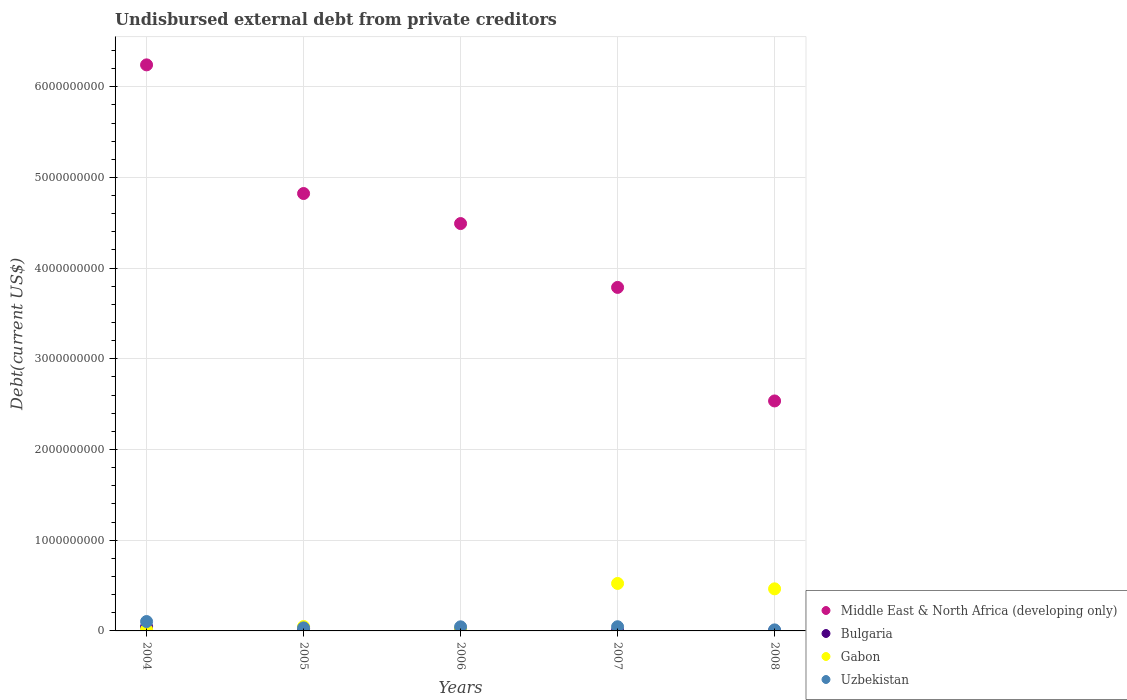How many different coloured dotlines are there?
Your answer should be compact. 4. What is the total debt in Gabon in 2006?
Your answer should be compact. 2.54e+07. Across all years, what is the maximum total debt in Gabon?
Make the answer very short. 5.23e+08. Across all years, what is the minimum total debt in Uzbekistan?
Make the answer very short. 1.14e+07. In which year was the total debt in Gabon maximum?
Provide a short and direct response. 2007. What is the total total debt in Gabon in the graph?
Your answer should be compact. 1.08e+09. What is the difference between the total debt in Uzbekistan in 2004 and that in 2005?
Offer a very short reply. 7.00e+07. What is the difference between the total debt in Uzbekistan in 2005 and the total debt in Gabon in 2008?
Your response must be concise. -4.30e+08. What is the average total debt in Uzbekistan per year?
Provide a short and direct response. 4.79e+07. In the year 2006, what is the difference between the total debt in Middle East & North Africa (developing only) and total debt in Bulgaria?
Give a very brief answer. 4.48e+09. What is the ratio of the total debt in Middle East & North Africa (developing only) in 2007 to that in 2008?
Your answer should be very brief. 1.49. Is the total debt in Uzbekistan in 2005 less than that in 2007?
Make the answer very short. Yes. What is the difference between the highest and the second highest total debt in Bulgaria?
Your response must be concise. 1.85e+07. What is the difference between the highest and the lowest total debt in Middle East & North Africa (developing only)?
Offer a very short reply. 3.71e+09. In how many years, is the total debt in Gabon greater than the average total debt in Gabon taken over all years?
Offer a terse response. 2. Is the sum of the total debt in Bulgaria in 2006 and 2007 greater than the maximum total debt in Uzbekistan across all years?
Offer a very short reply. No. How many dotlines are there?
Provide a short and direct response. 4. Are the values on the major ticks of Y-axis written in scientific E-notation?
Make the answer very short. No. Does the graph contain any zero values?
Make the answer very short. No. Where does the legend appear in the graph?
Give a very brief answer. Bottom right. How are the legend labels stacked?
Give a very brief answer. Vertical. What is the title of the graph?
Provide a succinct answer. Undisbursed external debt from private creditors. What is the label or title of the Y-axis?
Offer a very short reply. Debt(current US$). What is the Debt(current US$) of Middle East & North Africa (developing only) in 2004?
Offer a terse response. 6.24e+09. What is the Debt(current US$) in Bulgaria in 2004?
Offer a terse response. 4.61e+07. What is the Debt(current US$) of Gabon in 2004?
Your answer should be very brief. 1.48e+07. What is the Debt(current US$) of Uzbekistan in 2004?
Keep it short and to the point. 1.03e+08. What is the Debt(current US$) in Middle East & North Africa (developing only) in 2005?
Offer a very short reply. 4.82e+09. What is the Debt(current US$) of Bulgaria in 2005?
Make the answer very short. 2.76e+07. What is the Debt(current US$) in Gabon in 2005?
Your response must be concise. 4.86e+07. What is the Debt(current US$) of Uzbekistan in 2005?
Your response must be concise. 3.35e+07. What is the Debt(current US$) of Middle East & North Africa (developing only) in 2006?
Ensure brevity in your answer.  4.49e+09. What is the Debt(current US$) in Bulgaria in 2006?
Provide a succinct answer. 1.13e+07. What is the Debt(current US$) in Gabon in 2006?
Offer a terse response. 2.54e+07. What is the Debt(current US$) of Uzbekistan in 2006?
Your response must be concise. 4.53e+07. What is the Debt(current US$) in Middle East & North Africa (developing only) in 2007?
Provide a succinct answer. 3.79e+09. What is the Debt(current US$) of Bulgaria in 2007?
Your response must be concise. 4.57e+06. What is the Debt(current US$) in Gabon in 2007?
Offer a very short reply. 5.23e+08. What is the Debt(current US$) in Uzbekistan in 2007?
Your response must be concise. 4.61e+07. What is the Debt(current US$) of Middle East & North Africa (developing only) in 2008?
Your answer should be very brief. 2.54e+09. What is the Debt(current US$) of Bulgaria in 2008?
Your response must be concise. 2.36e+06. What is the Debt(current US$) of Gabon in 2008?
Offer a very short reply. 4.64e+08. What is the Debt(current US$) in Uzbekistan in 2008?
Ensure brevity in your answer.  1.14e+07. Across all years, what is the maximum Debt(current US$) in Middle East & North Africa (developing only)?
Keep it short and to the point. 6.24e+09. Across all years, what is the maximum Debt(current US$) of Bulgaria?
Your answer should be very brief. 4.61e+07. Across all years, what is the maximum Debt(current US$) of Gabon?
Your answer should be very brief. 5.23e+08. Across all years, what is the maximum Debt(current US$) of Uzbekistan?
Your answer should be very brief. 1.03e+08. Across all years, what is the minimum Debt(current US$) of Middle East & North Africa (developing only)?
Ensure brevity in your answer.  2.54e+09. Across all years, what is the minimum Debt(current US$) in Bulgaria?
Your answer should be compact. 2.36e+06. Across all years, what is the minimum Debt(current US$) in Gabon?
Give a very brief answer. 1.48e+07. Across all years, what is the minimum Debt(current US$) in Uzbekistan?
Keep it short and to the point. 1.14e+07. What is the total Debt(current US$) in Middle East & North Africa (developing only) in the graph?
Your response must be concise. 2.19e+1. What is the total Debt(current US$) of Bulgaria in the graph?
Your answer should be very brief. 9.19e+07. What is the total Debt(current US$) in Gabon in the graph?
Give a very brief answer. 1.08e+09. What is the total Debt(current US$) in Uzbekistan in the graph?
Provide a short and direct response. 2.40e+08. What is the difference between the Debt(current US$) of Middle East & North Africa (developing only) in 2004 and that in 2005?
Ensure brevity in your answer.  1.42e+09. What is the difference between the Debt(current US$) of Bulgaria in 2004 and that in 2005?
Your answer should be very brief. 1.85e+07. What is the difference between the Debt(current US$) of Gabon in 2004 and that in 2005?
Offer a terse response. -3.39e+07. What is the difference between the Debt(current US$) of Uzbekistan in 2004 and that in 2005?
Your answer should be very brief. 7.00e+07. What is the difference between the Debt(current US$) of Middle East & North Africa (developing only) in 2004 and that in 2006?
Offer a terse response. 1.75e+09. What is the difference between the Debt(current US$) in Bulgaria in 2004 and that in 2006?
Provide a succinct answer. 3.48e+07. What is the difference between the Debt(current US$) in Gabon in 2004 and that in 2006?
Provide a short and direct response. -1.07e+07. What is the difference between the Debt(current US$) in Uzbekistan in 2004 and that in 2006?
Offer a terse response. 5.82e+07. What is the difference between the Debt(current US$) in Middle East & North Africa (developing only) in 2004 and that in 2007?
Give a very brief answer. 2.45e+09. What is the difference between the Debt(current US$) of Bulgaria in 2004 and that in 2007?
Give a very brief answer. 4.15e+07. What is the difference between the Debt(current US$) of Gabon in 2004 and that in 2007?
Ensure brevity in your answer.  -5.09e+08. What is the difference between the Debt(current US$) in Uzbekistan in 2004 and that in 2007?
Keep it short and to the point. 5.74e+07. What is the difference between the Debt(current US$) in Middle East & North Africa (developing only) in 2004 and that in 2008?
Give a very brief answer. 3.71e+09. What is the difference between the Debt(current US$) of Bulgaria in 2004 and that in 2008?
Your answer should be compact. 4.37e+07. What is the difference between the Debt(current US$) of Gabon in 2004 and that in 2008?
Your answer should be compact. -4.49e+08. What is the difference between the Debt(current US$) in Uzbekistan in 2004 and that in 2008?
Keep it short and to the point. 9.21e+07. What is the difference between the Debt(current US$) in Middle East & North Africa (developing only) in 2005 and that in 2006?
Give a very brief answer. 3.31e+08. What is the difference between the Debt(current US$) in Bulgaria in 2005 and that in 2006?
Ensure brevity in your answer.  1.62e+07. What is the difference between the Debt(current US$) of Gabon in 2005 and that in 2006?
Your response must be concise. 2.32e+07. What is the difference between the Debt(current US$) in Uzbekistan in 2005 and that in 2006?
Make the answer very short. -1.18e+07. What is the difference between the Debt(current US$) of Middle East & North Africa (developing only) in 2005 and that in 2007?
Make the answer very short. 1.04e+09. What is the difference between the Debt(current US$) in Bulgaria in 2005 and that in 2007?
Ensure brevity in your answer.  2.30e+07. What is the difference between the Debt(current US$) in Gabon in 2005 and that in 2007?
Provide a short and direct response. -4.75e+08. What is the difference between the Debt(current US$) in Uzbekistan in 2005 and that in 2007?
Offer a very short reply. -1.26e+07. What is the difference between the Debt(current US$) of Middle East & North Africa (developing only) in 2005 and that in 2008?
Your answer should be very brief. 2.29e+09. What is the difference between the Debt(current US$) in Bulgaria in 2005 and that in 2008?
Your answer should be compact. 2.52e+07. What is the difference between the Debt(current US$) in Gabon in 2005 and that in 2008?
Your answer should be very brief. -4.15e+08. What is the difference between the Debt(current US$) in Uzbekistan in 2005 and that in 2008?
Your answer should be very brief. 2.21e+07. What is the difference between the Debt(current US$) in Middle East & North Africa (developing only) in 2006 and that in 2007?
Provide a succinct answer. 7.04e+08. What is the difference between the Debt(current US$) in Bulgaria in 2006 and that in 2007?
Keep it short and to the point. 6.77e+06. What is the difference between the Debt(current US$) in Gabon in 2006 and that in 2007?
Give a very brief answer. -4.98e+08. What is the difference between the Debt(current US$) of Uzbekistan in 2006 and that in 2007?
Provide a succinct answer. -8.14e+05. What is the difference between the Debt(current US$) of Middle East & North Africa (developing only) in 2006 and that in 2008?
Your answer should be compact. 1.96e+09. What is the difference between the Debt(current US$) in Bulgaria in 2006 and that in 2008?
Offer a very short reply. 8.98e+06. What is the difference between the Debt(current US$) of Gabon in 2006 and that in 2008?
Offer a very short reply. -4.39e+08. What is the difference between the Debt(current US$) in Uzbekistan in 2006 and that in 2008?
Give a very brief answer. 3.39e+07. What is the difference between the Debt(current US$) of Middle East & North Africa (developing only) in 2007 and that in 2008?
Keep it short and to the point. 1.25e+09. What is the difference between the Debt(current US$) in Bulgaria in 2007 and that in 2008?
Your response must be concise. 2.21e+06. What is the difference between the Debt(current US$) of Gabon in 2007 and that in 2008?
Offer a terse response. 5.94e+07. What is the difference between the Debt(current US$) of Uzbekistan in 2007 and that in 2008?
Your response must be concise. 3.47e+07. What is the difference between the Debt(current US$) of Middle East & North Africa (developing only) in 2004 and the Debt(current US$) of Bulgaria in 2005?
Your response must be concise. 6.21e+09. What is the difference between the Debt(current US$) in Middle East & North Africa (developing only) in 2004 and the Debt(current US$) in Gabon in 2005?
Make the answer very short. 6.19e+09. What is the difference between the Debt(current US$) of Middle East & North Africa (developing only) in 2004 and the Debt(current US$) of Uzbekistan in 2005?
Your response must be concise. 6.21e+09. What is the difference between the Debt(current US$) in Bulgaria in 2004 and the Debt(current US$) in Gabon in 2005?
Provide a succinct answer. -2.54e+06. What is the difference between the Debt(current US$) of Bulgaria in 2004 and the Debt(current US$) of Uzbekistan in 2005?
Give a very brief answer. 1.26e+07. What is the difference between the Debt(current US$) of Gabon in 2004 and the Debt(current US$) of Uzbekistan in 2005?
Your answer should be very brief. -1.87e+07. What is the difference between the Debt(current US$) of Middle East & North Africa (developing only) in 2004 and the Debt(current US$) of Bulgaria in 2006?
Offer a very short reply. 6.23e+09. What is the difference between the Debt(current US$) of Middle East & North Africa (developing only) in 2004 and the Debt(current US$) of Gabon in 2006?
Make the answer very short. 6.22e+09. What is the difference between the Debt(current US$) of Middle East & North Africa (developing only) in 2004 and the Debt(current US$) of Uzbekistan in 2006?
Ensure brevity in your answer.  6.20e+09. What is the difference between the Debt(current US$) in Bulgaria in 2004 and the Debt(current US$) in Gabon in 2006?
Give a very brief answer. 2.07e+07. What is the difference between the Debt(current US$) of Bulgaria in 2004 and the Debt(current US$) of Uzbekistan in 2006?
Provide a succinct answer. 8.32e+05. What is the difference between the Debt(current US$) of Gabon in 2004 and the Debt(current US$) of Uzbekistan in 2006?
Offer a very short reply. -3.05e+07. What is the difference between the Debt(current US$) in Middle East & North Africa (developing only) in 2004 and the Debt(current US$) in Bulgaria in 2007?
Offer a very short reply. 6.24e+09. What is the difference between the Debt(current US$) of Middle East & North Africa (developing only) in 2004 and the Debt(current US$) of Gabon in 2007?
Offer a terse response. 5.72e+09. What is the difference between the Debt(current US$) in Middle East & North Africa (developing only) in 2004 and the Debt(current US$) in Uzbekistan in 2007?
Offer a very short reply. 6.20e+09. What is the difference between the Debt(current US$) of Bulgaria in 2004 and the Debt(current US$) of Gabon in 2007?
Provide a succinct answer. -4.77e+08. What is the difference between the Debt(current US$) of Bulgaria in 2004 and the Debt(current US$) of Uzbekistan in 2007?
Provide a succinct answer. 1.80e+04. What is the difference between the Debt(current US$) in Gabon in 2004 and the Debt(current US$) in Uzbekistan in 2007?
Give a very brief answer. -3.13e+07. What is the difference between the Debt(current US$) of Middle East & North Africa (developing only) in 2004 and the Debt(current US$) of Bulgaria in 2008?
Give a very brief answer. 6.24e+09. What is the difference between the Debt(current US$) of Middle East & North Africa (developing only) in 2004 and the Debt(current US$) of Gabon in 2008?
Give a very brief answer. 5.78e+09. What is the difference between the Debt(current US$) in Middle East & North Africa (developing only) in 2004 and the Debt(current US$) in Uzbekistan in 2008?
Provide a succinct answer. 6.23e+09. What is the difference between the Debt(current US$) of Bulgaria in 2004 and the Debt(current US$) of Gabon in 2008?
Give a very brief answer. -4.18e+08. What is the difference between the Debt(current US$) of Bulgaria in 2004 and the Debt(current US$) of Uzbekistan in 2008?
Ensure brevity in your answer.  3.47e+07. What is the difference between the Debt(current US$) in Gabon in 2004 and the Debt(current US$) in Uzbekistan in 2008?
Offer a very short reply. 3.39e+06. What is the difference between the Debt(current US$) of Middle East & North Africa (developing only) in 2005 and the Debt(current US$) of Bulgaria in 2006?
Offer a very short reply. 4.81e+09. What is the difference between the Debt(current US$) in Middle East & North Africa (developing only) in 2005 and the Debt(current US$) in Gabon in 2006?
Ensure brevity in your answer.  4.80e+09. What is the difference between the Debt(current US$) of Middle East & North Africa (developing only) in 2005 and the Debt(current US$) of Uzbekistan in 2006?
Your response must be concise. 4.78e+09. What is the difference between the Debt(current US$) in Bulgaria in 2005 and the Debt(current US$) in Gabon in 2006?
Provide a short and direct response. 2.13e+06. What is the difference between the Debt(current US$) in Bulgaria in 2005 and the Debt(current US$) in Uzbekistan in 2006?
Ensure brevity in your answer.  -1.77e+07. What is the difference between the Debt(current US$) of Gabon in 2005 and the Debt(current US$) of Uzbekistan in 2006?
Provide a short and direct response. 3.37e+06. What is the difference between the Debt(current US$) in Middle East & North Africa (developing only) in 2005 and the Debt(current US$) in Bulgaria in 2007?
Provide a succinct answer. 4.82e+09. What is the difference between the Debt(current US$) of Middle East & North Africa (developing only) in 2005 and the Debt(current US$) of Gabon in 2007?
Your answer should be very brief. 4.30e+09. What is the difference between the Debt(current US$) in Middle East & North Africa (developing only) in 2005 and the Debt(current US$) in Uzbekistan in 2007?
Ensure brevity in your answer.  4.78e+09. What is the difference between the Debt(current US$) of Bulgaria in 2005 and the Debt(current US$) of Gabon in 2007?
Offer a terse response. -4.96e+08. What is the difference between the Debt(current US$) in Bulgaria in 2005 and the Debt(current US$) in Uzbekistan in 2007?
Provide a succinct answer. -1.85e+07. What is the difference between the Debt(current US$) in Gabon in 2005 and the Debt(current US$) in Uzbekistan in 2007?
Keep it short and to the point. 2.55e+06. What is the difference between the Debt(current US$) of Middle East & North Africa (developing only) in 2005 and the Debt(current US$) of Bulgaria in 2008?
Give a very brief answer. 4.82e+09. What is the difference between the Debt(current US$) in Middle East & North Africa (developing only) in 2005 and the Debt(current US$) in Gabon in 2008?
Your answer should be compact. 4.36e+09. What is the difference between the Debt(current US$) in Middle East & North Africa (developing only) in 2005 and the Debt(current US$) in Uzbekistan in 2008?
Provide a short and direct response. 4.81e+09. What is the difference between the Debt(current US$) in Bulgaria in 2005 and the Debt(current US$) in Gabon in 2008?
Keep it short and to the point. -4.36e+08. What is the difference between the Debt(current US$) in Bulgaria in 2005 and the Debt(current US$) in Uzbekistan in 2008?
Make the answer very short. 1.62e+07. What is the difference between the Debt(current US$) of Gabon in 2005 and the Debt(current US$) of Uzbekistan in 2008?
Your answer should be very brief. 3.73e+07. What is the difference between the Debt(current US$) in Middle East & North Africa (developing only) in 2006 and the Debt(current US$) in Bulgaria in 2007?
Offer a very short reply. 4.49e+09. What is the difference between the Debt(current US$) of Middle East & North Africa (developing only) in 2006 and the Debt(current US$) of Gabon in 2007?
Your answer should be compact. 3.97e+09. What is the difference between the Debt(current US$) in Middle East & North Africa (developing only) in 2006 and the Debt(current US$) in Uzbekistan in 2007?
Offer a terse response. 4.45e+09. What is the difference between the Debt(current US$) in Bulgaria in 2006 and the Debt(current US$) in Gabon in 2007?
Provide a short and direct response. -5.12e+08. What is the difference between the Debt(current US$) of Bulgaria in 2006 and the Debt(current US$) of Uzbekistan in 2007?
Your answer should be compact. -3.47e+07. What is the difference between the Debt(current US$) in Gabon in 2006 and the Debt(current US$) in Uzbekistan in 2007?
Make the answer very short. -2.06e+07. What is the difference between the Debt(current US$) of Middle East & North Africa (developing only) in 2006 and the Debt(current US$) of Bulgaria in 2008?
Offer a terse response. 4.49e+09. What is the difference between the Debt(current US$) in Middle East & North Africa (developing only) in 2006 and the Debt(current US$) in Gabon in 2008?
Your response must be concise. 4.03e+09. What is the difference between the Debt(current US$) of Middle East & North Africa (developing only) in 2006 and the Debt(current US$) of Uzbekistan in 2008?
Your answer should be very brief. 4.48e+09. What is the difference between the Debt(current US$) in Bulgaria in 2006 and the Debt(current US$) in Gabon in 2008?
Your response must be concise. -4.53e+08. What is the difference between the Debt(current US$) of Bulgaria in 2006 and the Debt(current US$) of Uzbekistan in 2008?
Your answer should be compact. -4.10e+04. What is the difference between the Debt(current US$) in Gabon in 2006 and the Debt(current US$) in Uzbekistan in 2008?
Your answer should be very brief. 1.41e+07. What is the difference between the Debt(current US$) of Middle East & North Africa (developing only) in 2007 and the Debt(current US$) of Bulgaria in 2008?
Offer a very short reply. 3.79e+09. What is the difference between the Debt(current US$) in Middle East & North Africa (developing only) in 2007 and the Debt(current US$) in Gabon in 2008?
Give a very brief answer. 3.32e+09. What is the difference between the Debt(current US$) in Middle East & North Africa (developing only) in 2007 and the Debt(current US$) in Uzbekistan in 2008?
Provide a succinct answer. 3.78e+09. What is the difference between the Debt(current US$) in Bulgaria in 2007 and the Debt(current US$) in Gabon in 2008?
Ensure brevity in your answer.  -4.59e+08. What is the difference between the Debt(current US$) of Bulgaria in 2007 and the Debt(current US$) of Uzbekistan in 2008?
Your answer should be compact. -6.81e+06. What is the difference between the Debt(current US$) of Gabon in 2007 and the Debt(current US$) of Uzbekistan in 2008?
Keep it short and to the point. 5.12e+08. What is the average Debt(current US$) in Middle East & North Africa (developing only) per year?
Offer a very short reply. 4.38e+09. What is the average Debt(current US$) in Bulgaria per year?
Give a very brief answer. 1.84e+07. What is the average Debt(current US$) in Gabon per year?
Your response must be concise. 2.15e+08. What is the average Debt(current US$) in Uzbekistan per year?
Offer a terse response. 4.79e+07. In the year 2004, what is the difference between the Debt(current US$) of Middle East & North Africa (developing only) and Debt(current US$) of Bulgaria?
Offer a very short reply. 6.20e+09. In the year 2004, what is the difference between the Debt(current US$) in Middle East & North Africa (developing only) and Debt(current US$) in Gabon?
Provide a short and direct response. 6.23e+09. In the year 2004, what is the difference between the Debt(current US$) of Middle East & North Africa (developing only) and Debt(current US$) of Uzbekistan?
Your answer should be very brief. 6.14e+09. In the year 2004, what is the difference between the Debt(current US$) in Bulgaria and Debt(current US$) in Gabon?
Your response must be concise. 3.13e+07. In the year 2004, what is the difference between the Debt(current US$) in Bulgaria and Debt(current US$) in Uzbekistan?
Make the answer very short. -5.74e+07. In the year 2004, what is the difference between the Debt(current US$) of Gabon and Debt(current US$) of Uzbekistan?
Your answer should be compact. -8.87e+07. In the year 2005, what is the difference between the Debt(current US$) in Middle East & North Africa (developing only) and Debt(current US$) in Bulgaria?
Your answer should be compact. 4.80e+09. In the year 2005, what is the difference between the Debt(current US$) of Middle East & North Africa (developing only) and Debt(current US$) of Gabon?
Offer a very short reply. 4.77e+09. In the year 2005, what is the difference between the Debt(current US$) of Middle East & North Africa (developing only) and Debt(current US$) of Uzbekistan?
Offer a very short reply. 4.79e+09. In the year 2005, what is the difference between the Debt(current US$) of Bulgaria and Debt(current US$) of Gabon?
Give a very brief answer. -2.11e+07. In the year 2005, what is the difference between the Debt(current US$) of Bulgaria and Debt(current US$) of Uzbekistan?
Provide a short and direct response. -5.93e+06. In the year 2005, what is the difference between the Debt(current US$) of Gabon and Debt(current US$) of Uzbekistan?
Offer a very short reply. 1.51e+07. In the year 2006, what is the difference between the Debt(current US$) of Middle East & North Africa (developing only) and Debt(current US$) of Bulgaria?
Your response must be concise. 4.48e+09. In the year 2006, what is the difference between the Debt(current US$) in Middle East & North Africa (developing only) and Debt(current US$) in Gabon?
Offer a very short reply. 4.47e+09. In the year 2006, what is the difference between the Debt(current US$) of Middle East & North Africa (developing only) and Debt(current US$) of Uzbekistan?
Provide a short and direct response. 4.45e+09. In the year 2006, what is the difference between the Debt(current US$) of Bulgaria and Debt(current US$) of Gabon?
Keep it short and to the point. -1.41e+07. In the year 2006, what is the difference between the Debt(current US$) in Bulgaria and Debt(current US$) in Uzbekistan?
Offer a very short reply. -3.39e+07. In the year 2006, what is the difference between the Debt(current US$) in Gabon and Debt(current US$) in Uzbekistan?
Provide a succinct answer. -1.98e+07. In the year 2007, what is the difference between the Debt(current US$) in Middle East & North Africa (developing only) and Debt(current US$) in Bulgaria?
Give a very brief answer. 3.78e+09. In the year 2007, what is the difference between the Debt(current US$) of Middle East & North Africa (developing only) and Debt(current US$) of Gabon?
Your answer should be compact. 3.26e+09. In the year 2007, what is the difference between the Debt(current US$) in Middle East & North Africa (developing only) and Debt(current US$) in Uzbekistan?
Provide a succinct answer. 3.74e+09. In the year 2007, what is the difference between the Debt(current US$) of Bulgaria and Debt(current US$) of Gabon?
Your response must be concise. -5.19e+08. In the year 2007, what is the difference between the Debt(current US$) of Bulgaria and Debt(current US$) of Uzbekistan?
Your response must be concise. -4.15e+07. In the year 2007, what is the difference between the Debt(current US$) in Gabon and Debt(current US$) in Uzbekistan?
Ensure brevity in your answer.  4.77e+08. In the year 2008, what is the difference between the Debt(current US$) in Middle East & North Africa (developing only) and Debt(current US$) in Bulgaria?
Provide a short and direct response. 2.53e+09. In the year 2008, what is the difference between the Debt(current US$) in Middle East & North Africa (developing only) and Debt(current US$) in Gabon?
Your response must be concise. 2.07e+09. In the year 2008, what is the difference between the Debt(current US$) in Middle East & North Africa (developing only) and Debt(current US$) in Uzbekistan?
Ensure brevity in your answer.  2.52e+09. In the year 2008, what is the difference between the Debt(current US$) of Bulgaria and Debt(current US$) of Gabon?
Provide a short and direct response. -4.62e+08. In the year 2008, what is the difference between the Debt(current US$) in Bulgaria and Debt(current US$) in Uzbekistan?
Keep it short and to the point. -9.02e+06. In the year 2008, what is the difference between the Debt(current US$) of Gabon and Debt(current US$) of Uzbekistan?
Offer a very short reply. 4.53e+08. What is the ratio of the Debt(current US$) in Middle East & North Africa (developing only) in 2004 to that in 2005?
Make the answer very short. 1.29. What is the ratio of the Debt(current US$) of Bulgaria in 2004 to that in 2005?
Your answer should be very brief. 1.67. What is the ratio of the Debt(current US$) in Gabon in 2004 to that in 2005?
Keep it short and to the point. 0.3. What is the ratio of the Debt(current US$) of Uzbekistan in 2004 to that in 2005?
Make the answer very short. 3.09. What is the ratio of the Debt(current US$) in Middle East & North Africa (developing only) in 2004 to that in 2006?
Your response must be concise. 1.39. What is the ratio of the Debt(current US$) of Bulgaria in 2004 to that in 2006?
Offer a terse response. 4.07. What is the ratio of the Debt(current US$) of Gabon in 2004 to that in 2006?
Provide a succinct answer. 0.58. What is the ratio of the Debt(current US$) of Uzbekistan in 2004 to that in 2006?
Keep it short and to the point. 2.29. What is the ratio of the Debt(current US$) in Middle East & North Africa (developing only) in 2004 to that in 2007?
Offer a very short reply. 1.65. What is the ratio of the Debt(current US$) of Bulgaria in 2004 to that in 2007?
Provide a short and direct response. 10.09. What is the ratio of the Debt(current US$) in Gabon in 2004 to that in 2007?
Provide a succinct answer. 0.03. What is the ratio of the Debt(current US$) of Uzbekistan in 2004 to that in 2007?
Keep it short and to the point. 2.25. What is the ratio of the Debt(current US$) of Middle East & North Africa (developing only) in 2004 to that in 2008?
Give a very brief answer. 2.46. What is the ratio of the Debt(current US$) in Bulgaria in 2004 to that in 2008?
Keep it short and to the point. 19.56. What is the ratio of the Debt(current US$) in Gabon in 2004 to that in 2008?
Your answer should be compact. 0.03. What is the ratio of the Debt(current US$) of Uzbekistan in 2004 to that in 2008?
Your answer should be very brief. 9.09. What is the ratio of the Debt(current US$) of Middle East & North Africa (developing only) in 2005 to that in 2006?
Your answer should be compact. 1.07. What is the ratio of the Debt(current US$) of Bulgaria in 2005 to that in 2006?
Ensure brevity in your answer.  2.43. What is the ratio of the Debt(current US$) of Gabon in 2005 to that in 2006?
Keep it short and to the point. 1.91. What is the ratio of the Debt(current US$) in Uzbekistan in 2005 to that in 2006?
Keep it short and to the point. 0.74. What is the ratio of the Debt(current US$) of Middle East & North Africa (developing only) in 2005 to that in 2007?
Offer a terse response. 1.27. What is the ratio of the Debt(current US$) of Bulgaria in 2005 to that in 2007?
Give a very brief answer. 6.03. What is the ratio of the Debt(current US$) in Gabon in 2005 to that in 2007?
Make the answer very short. 0.09. What is the ratio of the Debt(current US$) in Uzbekistan in 2005 to that in 2007?
Provide a short and direct response. 0.73. What is the ratio of the Debt(current US$) in Middle East & North Africa (developing only) in 2005 to that in 2008?
Make the answer very short. 1.9. What is the ratio of the Debt(current US$) in Bulgaria in 2005 to that in 2008?
Your answer should be very brief. 11.69. What is the ratio of the Debt(current US$) in Gabon in 2005 to that in 2008?
Provide a short and direct response. 0.1. What is the ratio of the Debt(current US$) of Uzbekistan in 2005 to that in 2008?
Your answer should be very brief. 2.94. What is the ratio of the Debt(current US$) of Middle East & North Africa (developing only) in 2006 to that in 2007?
Ensure brevity in your answer.  1.19. What is the ratio of the Debt(current US$) of Bulgaria in 2006 to that in 2007?
Provide a succinct answer. 2.48. What is the ratio of the Debt(current US$) of Gabon in 2006 to that in 2007?
Give a very brief answer. 0.05. What is the ratio of the Debt(current US$) of Uzbekistan in 2006 to that in 2007?
Offer a terse response. 0.98. What is the ratio of the Debt(current US$) in Middle East & North Africa (developing only) in 2006 to that in 2008?
Offer a very short reply. 1.77. What is the ratio of the Debt(current US$) in Bulgaria in 2006 to that in 2008?
Keep it short and to the point. 4.81. What is the ratio of the Debt(current US$) of Gabon in 2006 to that in 2008?
Keep it short and to the point. 0.05. What is the ratio of the Debt(current US$) in Uzbekistan in 2006 to that in 2008?
Make the answer very short. 3.98. What is the ratio of the Debt(current US$) of Middle East & North Africa (developing only) in 2007 to that in 2008?
Offer a terse response. 1.49. What is the ratio of the Debt(current US$) in Bulgaria in 2007 to that in 2008?
Your response must be concise. 1.94. What is the ratio of the Debt(current US$) in Gabon in 2007 to that in 2008?
Your answer should be compact. 1.13. What is the ratio of the Debt(current US$) in Uzbekistan in 2007 to that in 2008?
Provide a succinct answer. 4.05. What is the difference between the highest and the second highest Debt(current US$) of Middle East & North Africa (developing only)?
Provide a succinct answer. 1.42e+09. What is the difference between the highest and the second highest Debt(current US$) of Bulgaria?
Provide a succinct answer. 1.85e+07. What is the difference between the highest and the second highest Debt(current US$) of Gabon?
Offer a terse response. 5.94e+07. What is the difference between the highest and the second highest Debt(current US$) of Uzbekistan?
Your answer should be very brief. 5.74e+07. What is the difference between the highest and the lowest Debt(current US$) in Middle East & North Africa (developing only)?
Your answer should be very brief. 3.71e+09. What is the difference between the highest and the lowest Debt(current US$) in Bulgaria?
Provide a succinct answer. 4.37e+07. What is the difference between the highest and the lowest Debt(current US$) in Gabon?
Offer a very short reply. 5.09e+08. What is the difference between the highest and the lowest Debt(current US$) in Uzbekistan?
Your response must be concise. 9.21e+07. 